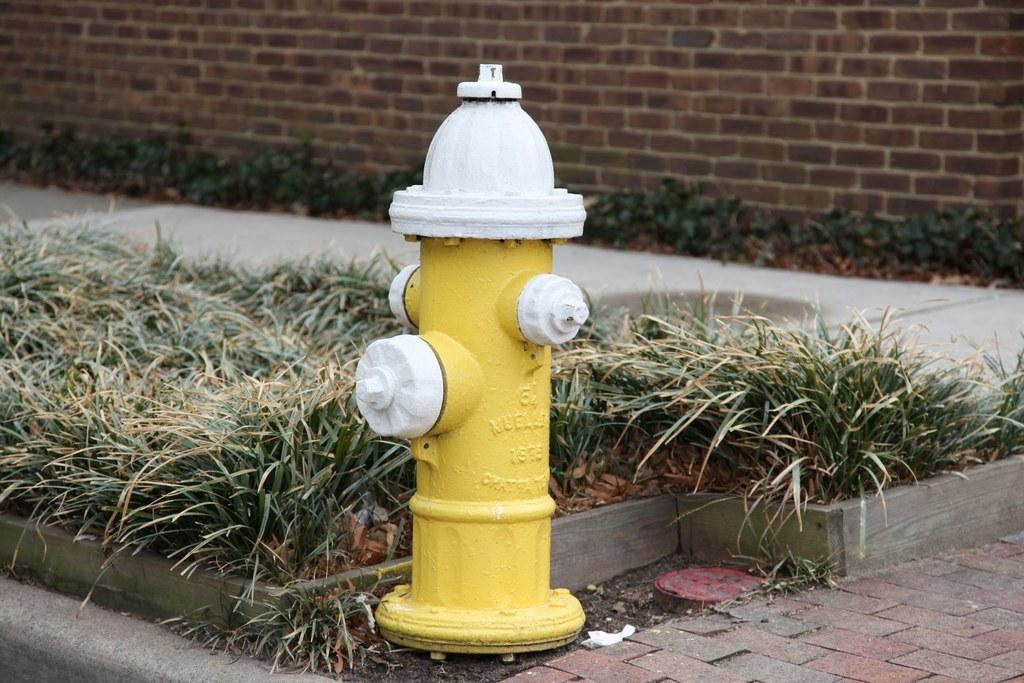What object is the main subject of the image? There is a fire-hydrant in the image. What colors are used to paint the fire-hydrant? The fire-hydrant is yellow and white in color. What type of vegetation can be seen in the image? There is green grass visible in the image. What type of structure is present in the background of the image? There is a brick wall in the image. Can you see your uncle's arm holding the fire-hydrant in the image? There is no person, including an uncle, present in the image, so there is no arm holding the fire-hydrant. 